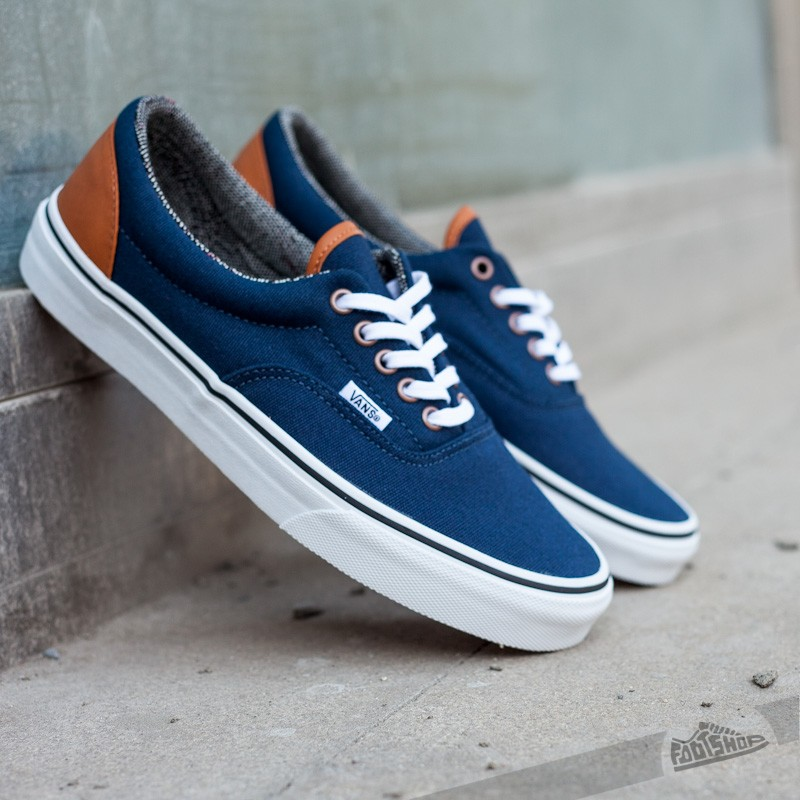Describe how you would use color theory to outfit someone styling these sneakers. Styling these navy and brown sneakers using color theory can be quite exciting. Navy is a versatile color that pairs well with many hues. For a complementary look, consider pairing the sneakers with shades of orange or rust for a bold statement. If a more subdued style is your preference, sticking to neutrals like beige, grey, and white can create a sleek and polished appearance. Additionally, incorporating a splash of denim can unify the outfit, given that blue is a dominant color in both the sneakers and popular clothing pieces. Accessorize with small touches of brown to tie in with the sneaker's accents. 